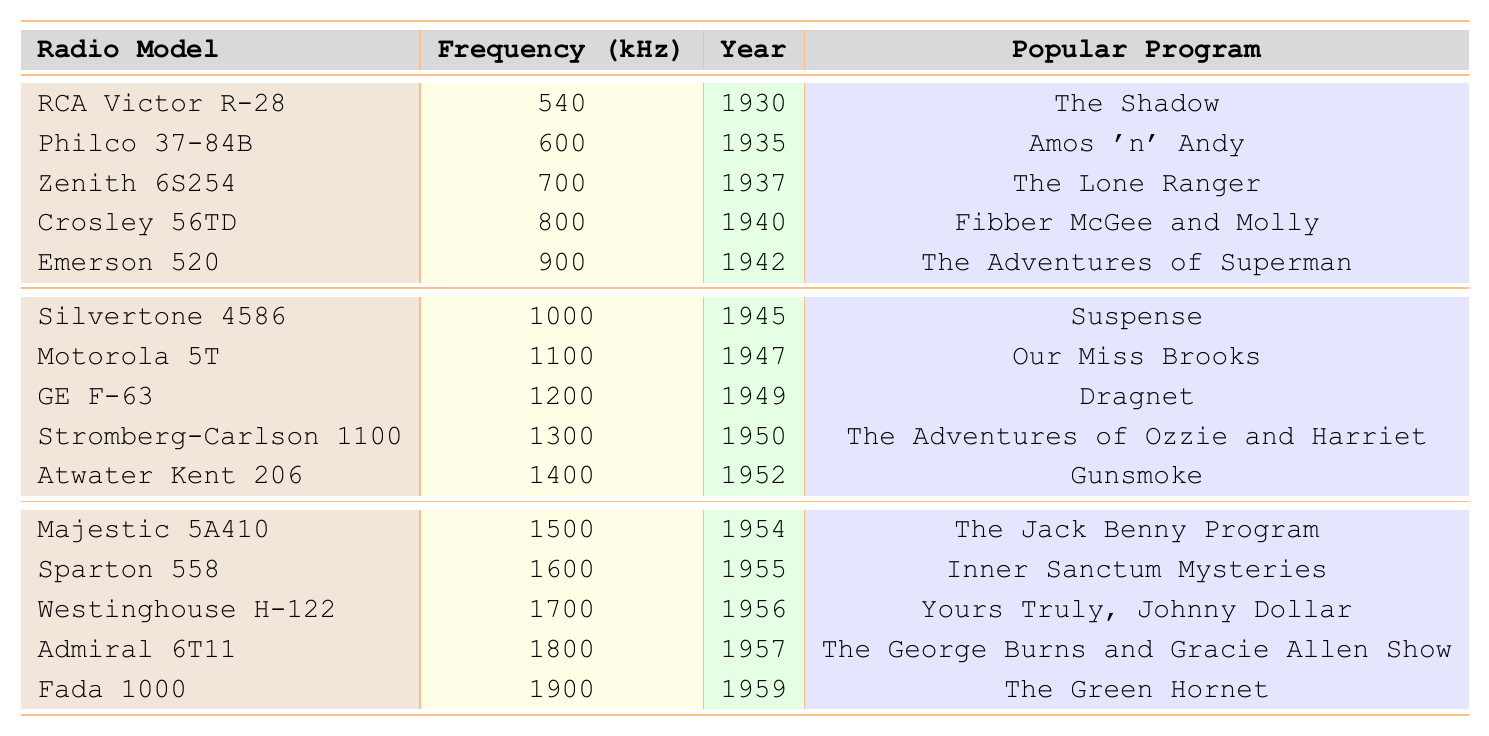What was the frequency of the RCA Victor R-28 radio model? The RCA Victor R-28 is listed in the table, and its frequency is shown in the respective column. It has a frequency of 540 kHz.
Answer: 540 kHz In what year was the Philco 37-84B radio model released? The Philco 37-84B model appears in the table under the Year column, indicating it was released in 1935.
Answer: 1935 Which radio model from the 1940s had the highest frequency? The table can be analyzed to identify the frequency of each radio model released in the 1940s. The highest frequency for this decade is 1300 kHz associated with the Stromberg-Carlson 1100 model.
Answer: Stromberg-Carlson 1100 What popular program was associated with the Zenith 6S254? By locating the Zenith 6S254 model in the table, the associated popular program can be found directly next to it. The program is "The Lone Ranger."
Answer: The Lone Ranger How many radio models were released in the year 1955? The table lists radio models with their corresponding years. By counting the instances of the year 1955, we find there is one radio model (Sparton 558) released in that year.
Answer: 1 Which two radio models had frequencies of 1000 kHz and 1100 kHz respectively? The table shows that the Silvertone 4586 has a frequency of 1000 kHz and the Motorola 5T has a frequency of 1100 kHz. Both can be identified in the frequencies column.
Answer: Silvertone 4586 and Motorola 5T What is the difference in frequencies between the Atwater Kent 206 and the Westinghouse H-122? By locating the frequencies of Atwater Kent 206 (1400 kHz) and Westinghouse H-122 (1700 kHz) in the table, the difference is calculated as 1700 - 1400 = 300 kHz.
Answer: 300 kHz Was there a radio model associated with the program "Gunsmoke"? The table can be checked for the program "Gunsmoke" to determine if it is linked to any radio model. It is indeed associated with Atwater Kent 206.
Answer: Yes What is the average frequency of the radio models listed for the year 1950? To find the average frequency, we first identify the radio model for the year 1950, which is the Stromberg-Carlson 1100 with a frequency of 1300 kHz. Since there is only one model, the average frequency is 1300 kHz / 1 = 1300 kHz.
Answer: 1300 kHz What popular program aired in the year 1942? The table shows that the Emerson 520 was released in 1942, with the popular program associated being "The Adventures of Superman."
Answer: The Adventures of Superman List the popular programs associated with the radio models released in the year 1956. The table indicates that the Westinghouse H-122, released in 1956, is linked with the program "Yours Truly, Johnny Dollar." This is the only program listed for that year.
Answer: Yours Truly, Johnny Dollar 